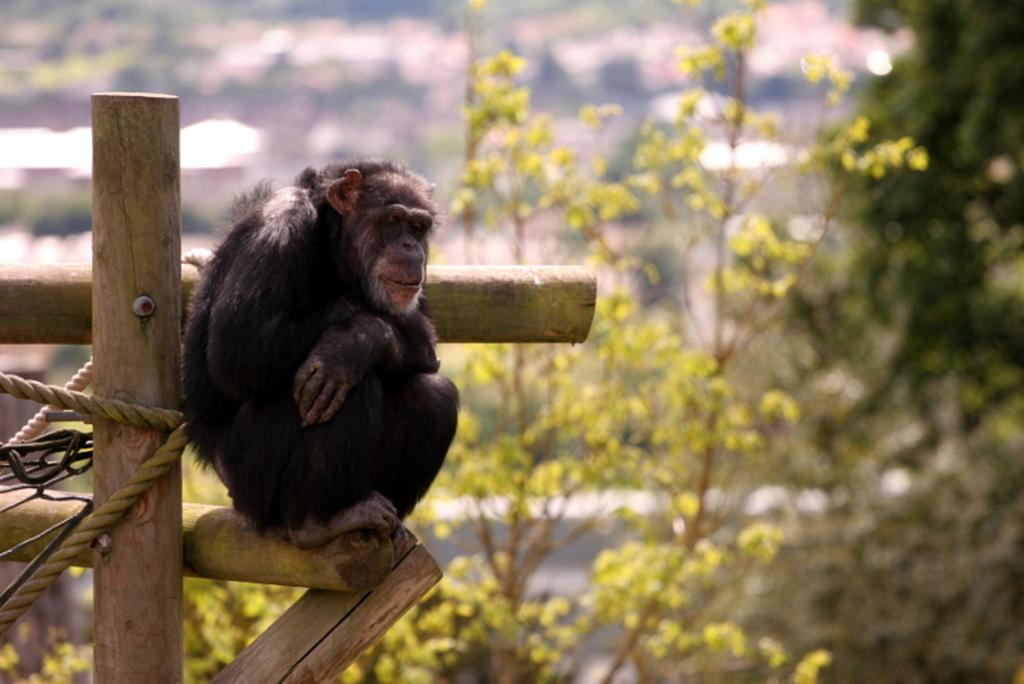What animal is present in the image? There is a monkey in the image. What is the monkey doing in the image? The monkey is sitting on a gate. What can be seen in the background of the image? There are trees in the background of the image. What type of lunch is the monkey eating in the image? There is no lunch present in the image; the monkey is sitting on a gate. What invention is the monkey using to climb the gate in the image? The monkey is not using any invention to climb the gate; it is sitting on the gate. 